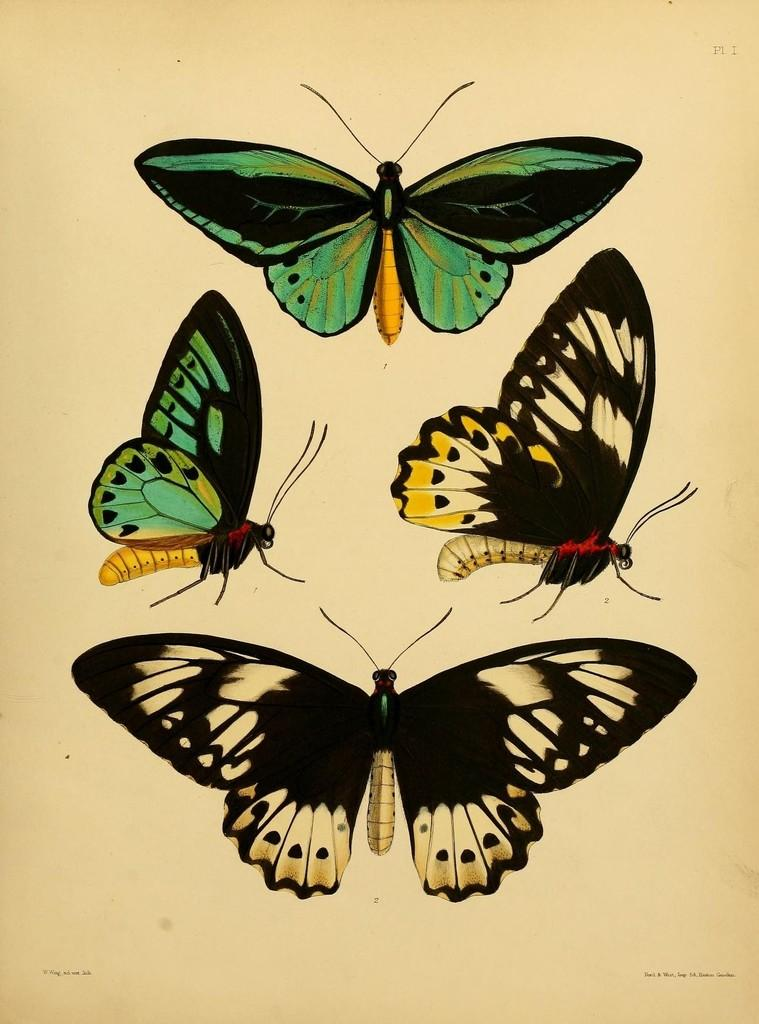How many butterflies are present in the image? There are five butterflies in the image. Where are the majority of the butterflies located? The majority of the butterflies are located in the middle of the image. Can you describe the positioning of the butterflies in relation to the image? There is one butterfly at the top side, four butterflies in the middle, and one butterfly at the bottom side of the image. What is the tendency of the butterflies to visit their friends in the image? There is no indication in the image of the butterflies visiting their friends, as the image only shows their positioning in relation to the image. 